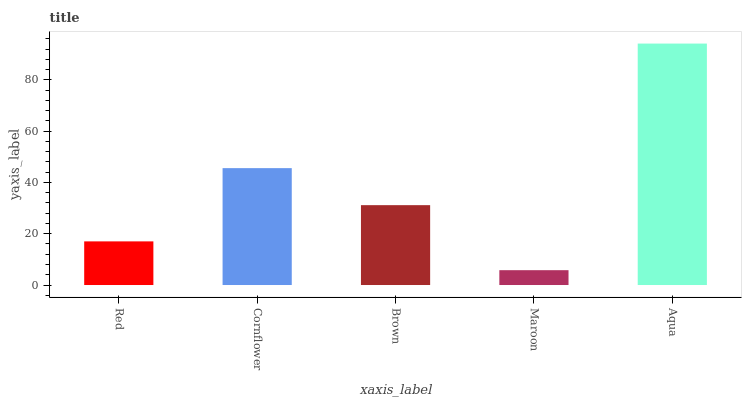Is Maroon the minimum?
Answer yes or no. Yes. Is Aqua the maximum?
Answer yes or no. Yes. Is Cornflower the minimum?
Answer yes or no. No. Is Cornflower the maximum?
Answer yes or no. No. Is Cornflower greater than Red?
Answer yes or no. Yes. Is Red less than Cornflower?
Answer yes or no. Yes. Is Red greater than Cornflower?
Answer yes or no. No. Is Cornflower less than Red?
Answer yes or no. No. Is Brown the high median?
Answer yes or no. Yes. Is Brown the low median?
Answer yes or no. Yes. Is Aqua the high median?
Answer yes or no. No. Is Aqua the low median?
Answer yes or no. No. 